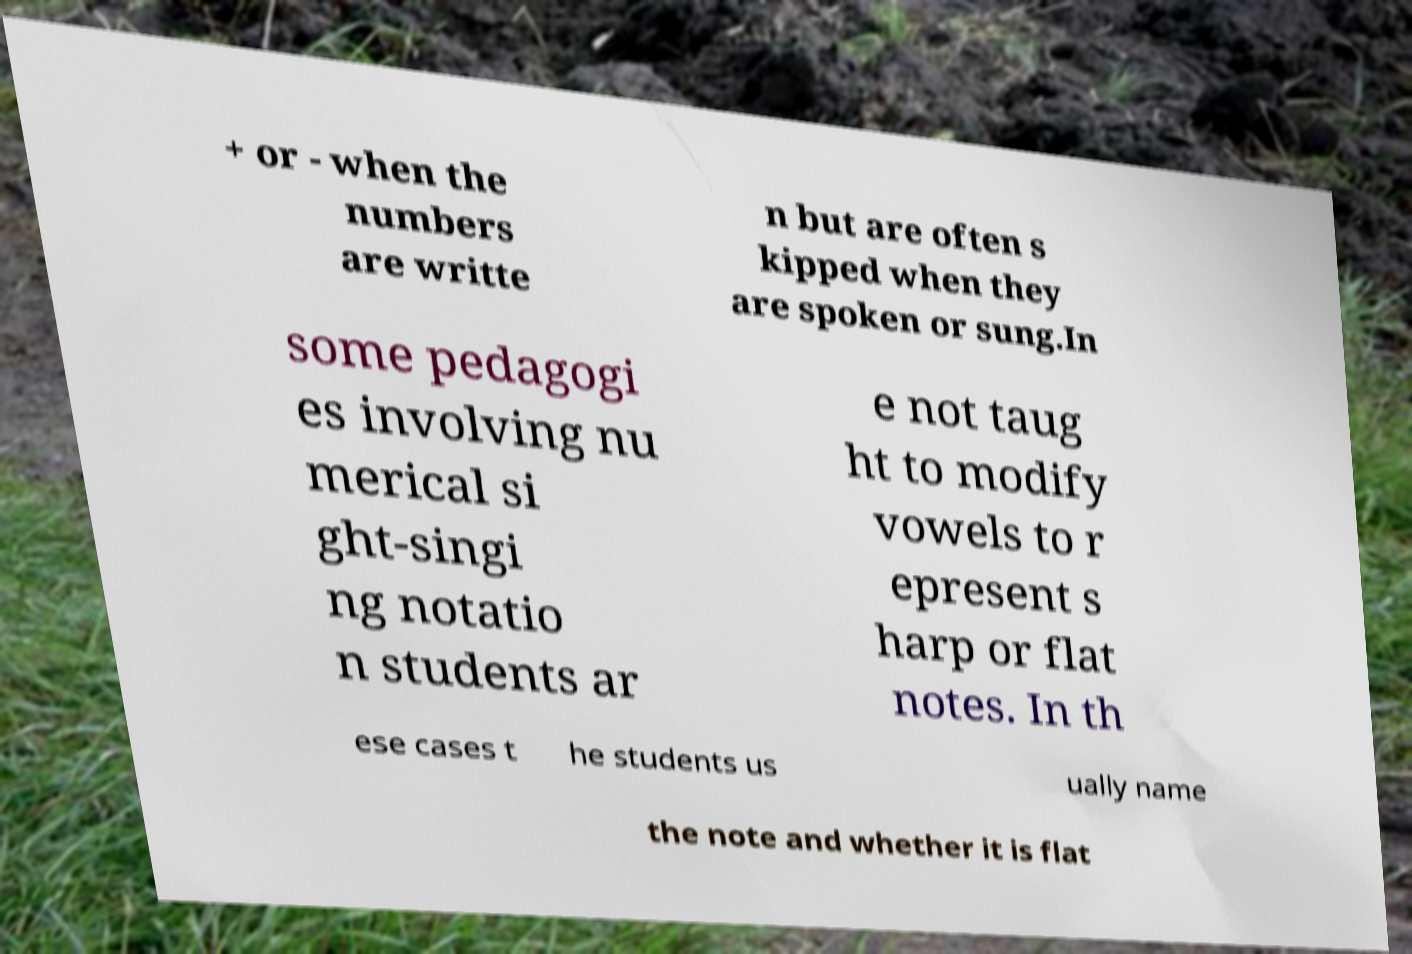Could you assist in decoding the text presented in this image and type it out clearly? + or - when the numbers are writte n but are often s kipped when they are spoken or sung.In some pedagogi es involving nu merical si ght-singi ng notatio n students ar e not taug ht to modify vowels to r epresent s harp or flat notes. In th ese cases t he students us ually name the note and whether it is flat 